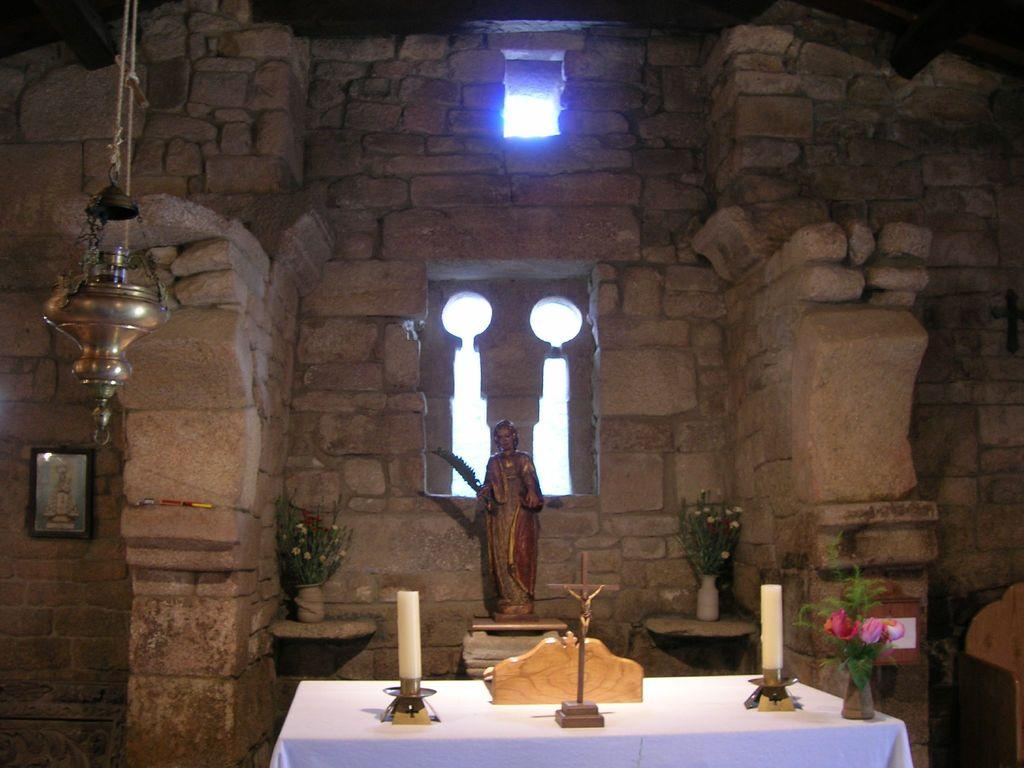What type of location is depicted in the image? The image shows the inside of a building. What decorative elements can be seen in the image? There are sculptures and flower pots in the image. What furniture piece is present in the image? There is a table with a white cloth in the image. Can you see any cobwebs hanging from the ceiling in the image? There is no mention of cobwebs in the provided facts, so we cannot determine if any are present in the image. --- Facts: 1. There is a person sitting on a chair in the image. 2. The person is holding a book. 3. The book has a blue cover. 4. There is a lamp on a table in the image. 5. The lamp has a yellow shade. Absurd Topics: parrot, bicycle, ocean Conversation: What is the person in the image doing? The person is sitting on a chair in the image. What object is the person holding? The person is holding a book. What color is the book's cover? The book has a blue cover. What is present on the table in the image? There is a lamp on a table in the image. What is the color of the lamp's shade? The lamp has a yellow shade. Reasoning: Let's think step by step in order to produce the conversation. We start by identifying the main subject in the image, which is the person sitting on a chair. Then, we describe the object the person is holding, which is a book with a blue cover. Next, we mention the presence of a lamp on a table and describe its shade color, which is yellow. Absurd Question/Answer: Is there a parrot sitting on the person's shoulder in the image? There is no mention of a parrot in the provided facts, so we cannot determine if one is present in the image. --- Facts: 1. There is a car in the image. 2. The car is red. 3. The car has four wheels. 4. There is a road in the image. 5. The road is paved. Absurd Topics: umbrella, rainbow, mountain Conversation: What vehicle is visible in the image? There is a car in the image. What color is the car? The car is red. How many wheels does the car have? The car has four wheels. What type of surface is the car driving on? There is a road in the image, and it is paved. Reasoning: Let's think step by step in order to produce the conversation. We start by identifying the main subject in the image, which is the car. Then, we describe the car's color and the number of wheels it has. Finally, we mention the type of surface the car is driving 